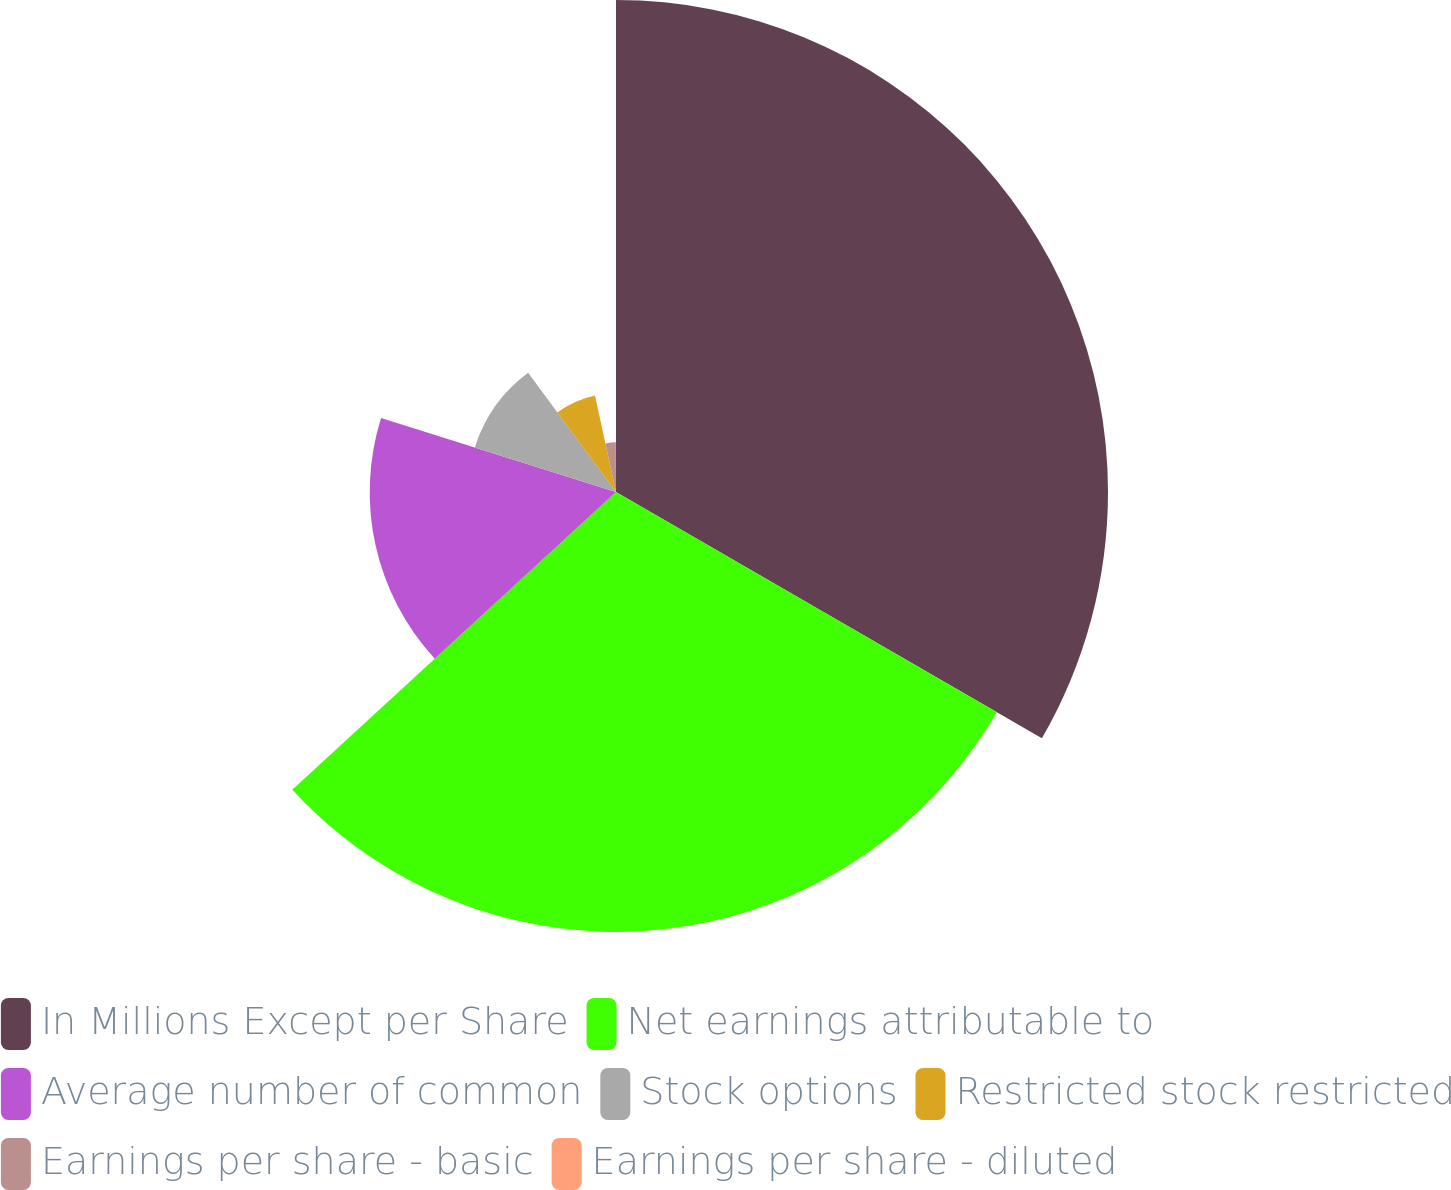Convert chart to OTSL. <chart><loc_0><loc_0><loc_500><loc_500><pie_chart><fcel>In Millions Except per Share<fcel>Net earnings attributable to<fcel>Average number of common<fcel>Stock options<fcel>Restricted stock restricted<fcel>Earnings per share - basic<fcel>Earnings per share - diluted<nl><fcel>33.34%<fcel>29.81%<fcel>16.69%<fcel>10.03%<fcel>6.7%<fcel>3.37%<fcel>0.04%<nl></chart> 